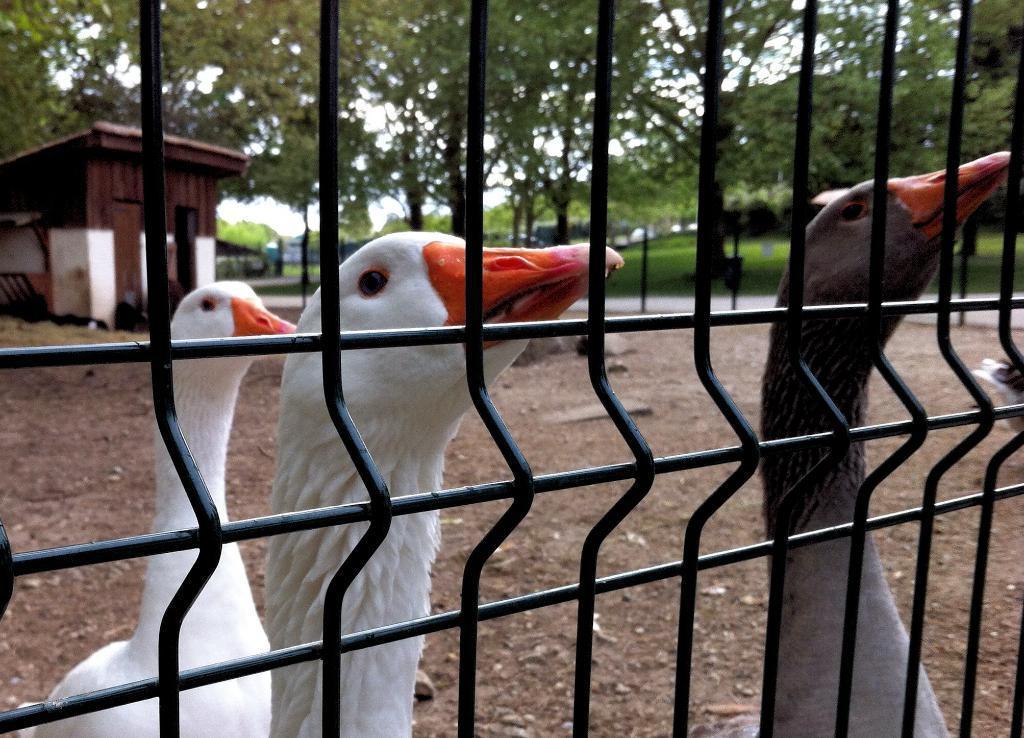In one or two sentences, can you explain what this image depicts? In this image in the front there is a cage and behind the cage there are birds. There are trees, there's grass on the ground and there is a hut. 